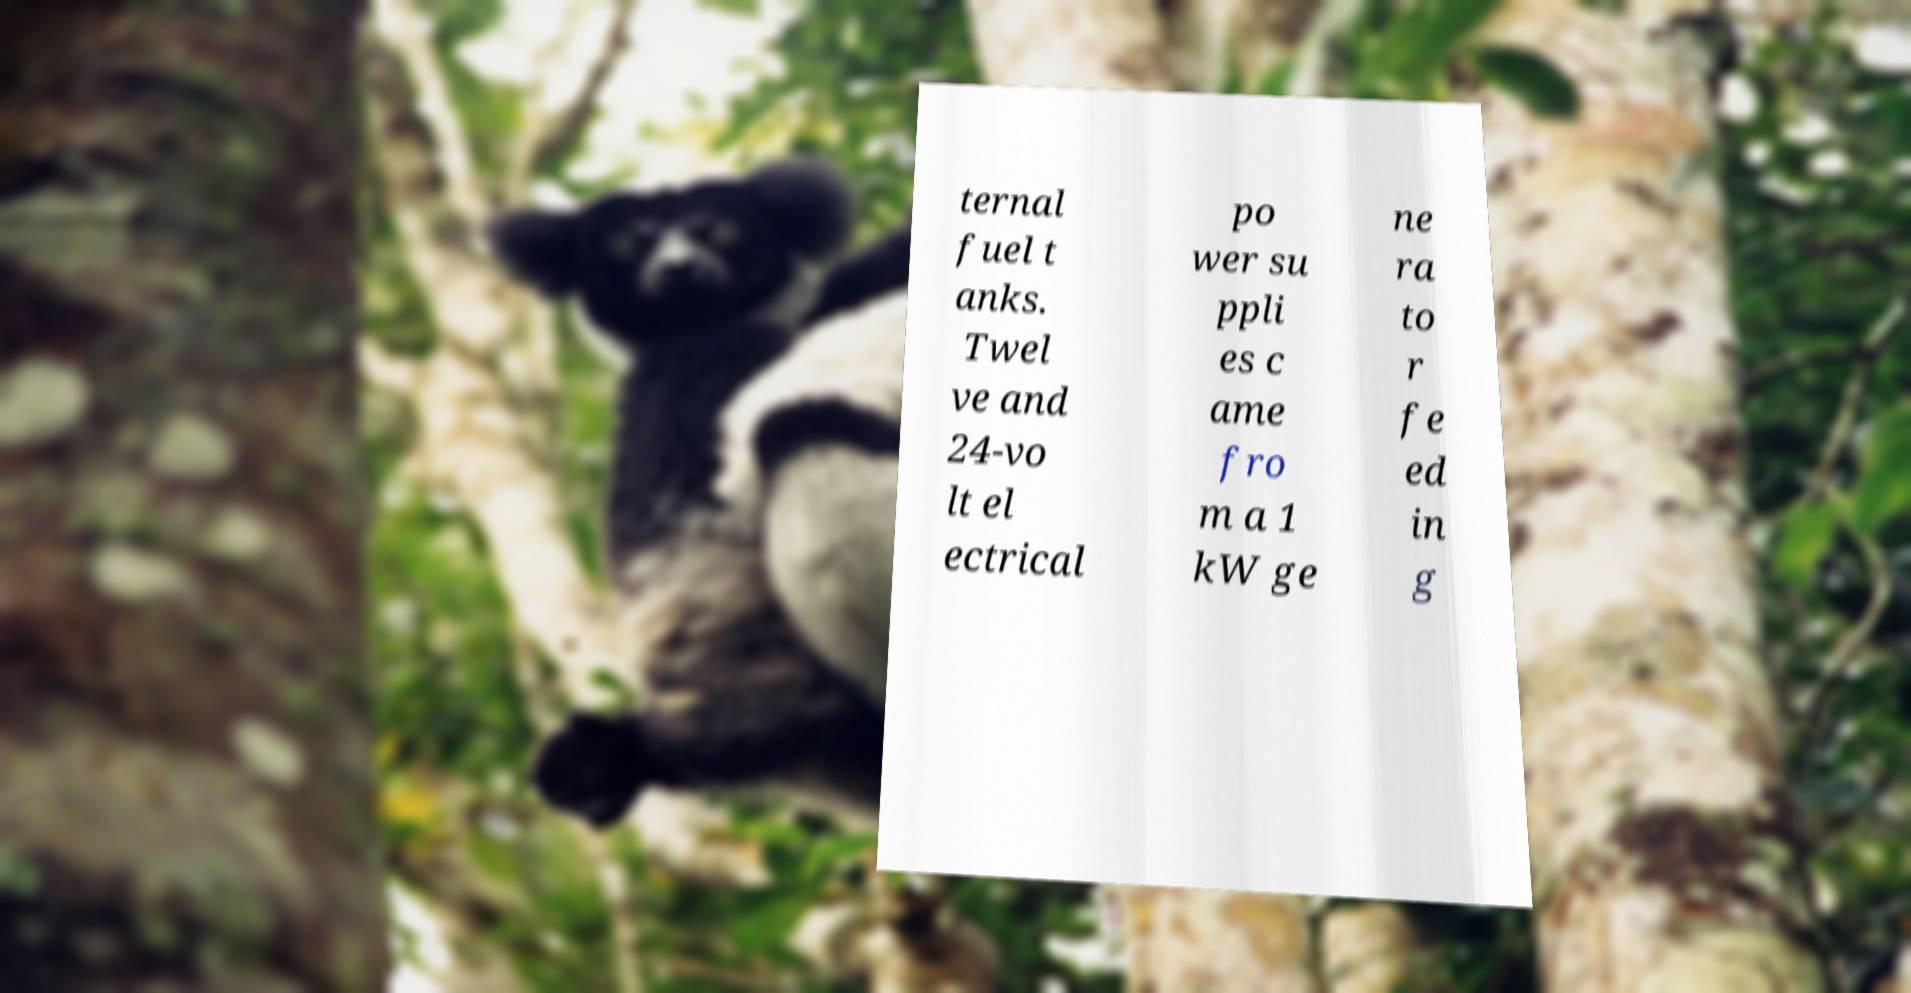Please identify and transcribe the text found in this image. ternal fuel t anks. Twel ve and 24-vo lt el ectrical po wer su ppli es c ame fro m a 1 kW ge ne ra to r fe ed in g 